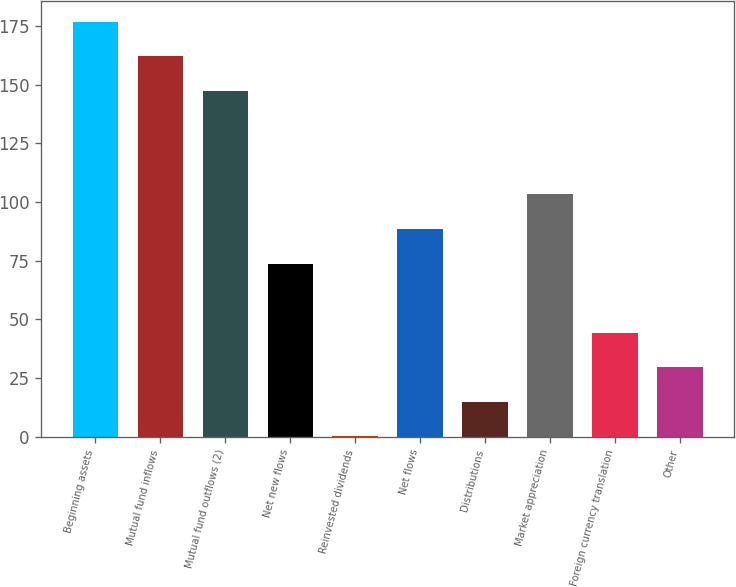Convert chart. <chart><loc_0><loc_0><loc_500><loc_500><bar_chart><fcel>Beginning assets<fcel>Mutual fund inflows<fcel>Mutual fund outflows (2)<fcel>Net new flows<fcel>Reinvested dividends<fcel>Net flows<fcel>Distributions<fcel>Market appreciation<fcel>Foreign currency translation<fcel>Other<nl><fcel>176.84<fcel>162.12<fcel>147.4<fcel>73.8<fcel>0.2<fcel>88.52<fcel>14.92<fcel>103.24<fcel>44.36<fcel>29.64<nl></chart> 